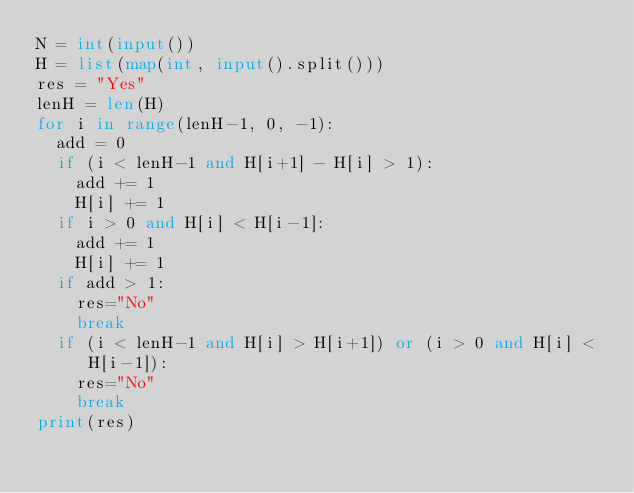<code> <loc_0><loc_0><loc_500><loc_500><_Python_>N = int(input())
H = list(map(int, input().split()))
res = "Yes"
lenH = len(H)
for i in range(lenH-1, 0, -1):
  add = 0
  if (i < lenH-1 and H[i+1] - H[i] > 1):
    add += 1
    H[i] += 1
  if i > 0 and H[i] < H[i-1]:
    add += 1
    H[i] += 1
  if add > 1:
    res="No"
    break
  if (i < lenH-1 and H[i] > H[i+1]) or (i > 0 and H[i] < H[i-1]):
    res="No"
    break
print(res)</code> 